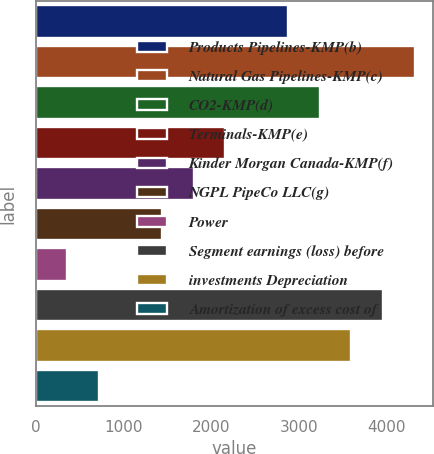<chart> <loc_0><loc_0><loc_500><loc_500><bar_chart><fcel>Products Pipelines-KMP(b)<fcel>Natural Gas Pipelines-KMP(c)<fcel>CO2-KMP(d)<fcel>Terminals-KMP(e)<fcel>Kinder Morgan Canada-KMP(f)<fcel>NGPL PipeCo LLC(g)<fcel>Power<fcel>Segment earnings (loss) before<fcel>investments Depreciation<fcel>Amortization of excess cost of<nl><fcel>2879.62<fcel>4318.98<fcel>3239.46<fcel>2159.94<fcel>1800.1<fcel>1440.26<fcel>360.74<fcel>3959.14<fcel>3599.3<fcel>720.58<nl></chart> 